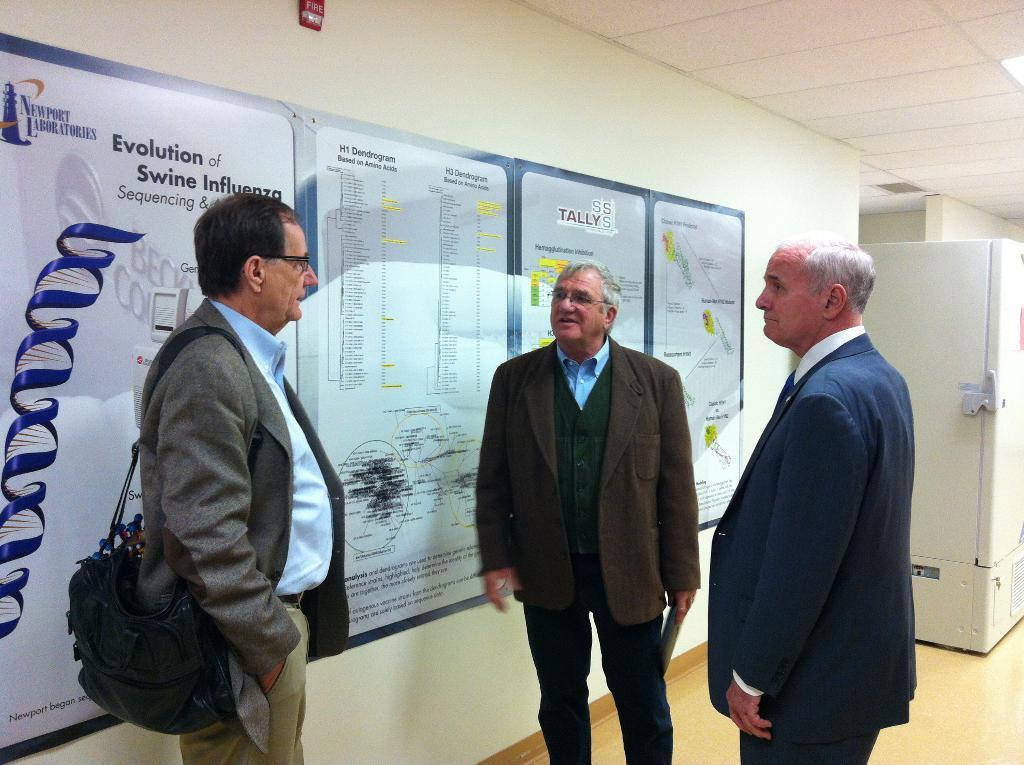How many people are present in the image? There are three persons standing in the image. Where are the persons standing? The persons are standing on the floor. What can be seen in the background of the image? There is a wall in the background of the image. What is attached to the wall in the background? Papers are attached to the wall in the background. What type of mine can be seen in the image? There is no mine present in the image. How many questions are being asked in the image? The image does not depict any questions being asked. 